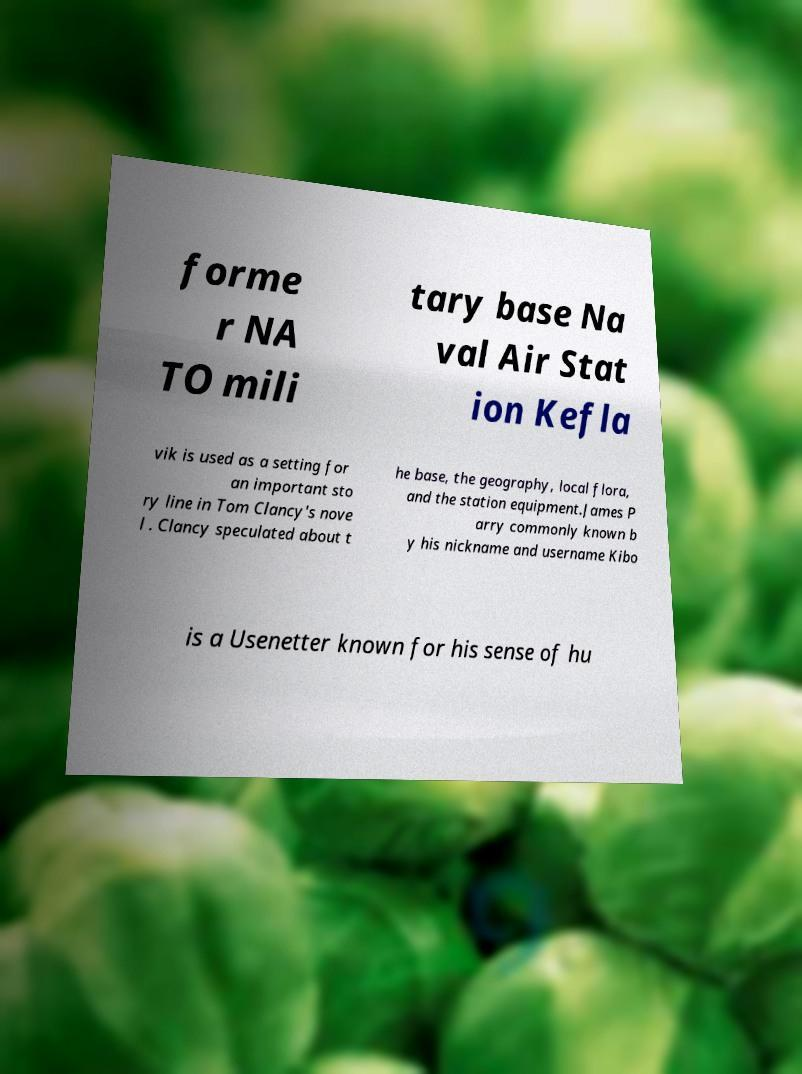For documentation purposes, I need the text within this image transcribed. Could you provide that? forme r NA TO mili tary base Na val Air Stat ion Kefla vik is used as a setting for an important sto ry line in Tom Clancy's nove l . Clancy speculated about t he base, the geography, local flora, and the station equipment.James P arry commonly known b y his nickname and username Kibo is a Usenetter known for his sense of hu 